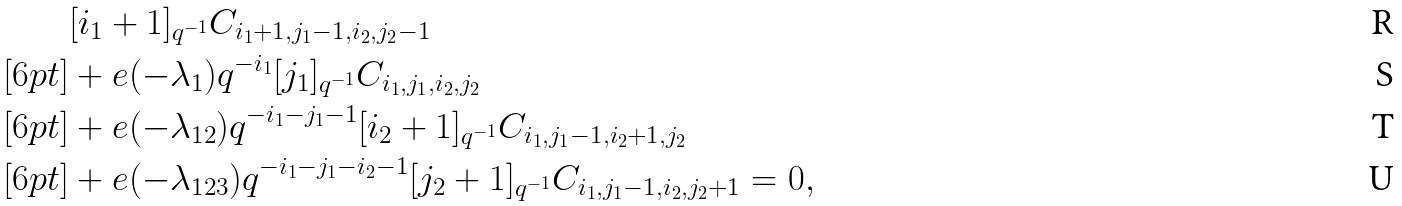Convert formula to latex. <formula><loc_0><loc_0><loc_500><loc_500>& [ i _ { 1 } + 1 ] _ { q ^ { - 1 } } C _ { i _ { 1 } + 1 , j _ { 1 } - 1 , i _ { 2 } , j _ { 2 } - 1 } \\ [ 6 p t ] & + e ( - \lambda _ { 1 } ) q ^ { - i _ { 1 } } [ j _ { 1 } ] _ { q ^ { - 1 } } C _ { i _ { 1 } , j _ { 1 } , i _ { 2 } , j _ { 2 } } \\ [ 6 p t ] & + e ( - \lambda _ { 1 2 } ) q ^ { - i _ { 1 } - j _ { 1 } - 1 } [ i _ { 2 } + 1 ] _ { q ^ { - 1 } } C _ { i _ { 1 } , j _ { 1 } - 1 , i _ { 2 } + 1 , j _ { 2 } } \\ [ 6 p t ] & + e ( - \lambda _ { 1 2 3 } ) q ^ { - i _ { 1 } - j _ { 1 } - i _ { 2 } - 1 } [ j _ { 2 } + 1 ] _ { q ^ { - 1 } } C _ { i _ { 1 } , j _ { 1 } - 1 , i _ { 2 } , j _ { 2 } + 1 } = 0 ,</formula> 